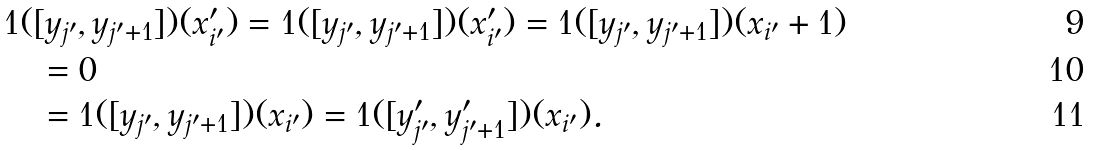Convert formula to latex. <formula><loc_0><loc_0><loc_500><loc_500>& 1 ( [ y _ { j ^ { \prime } } , y _ { j ^ { \prime } + 1 } ] ) ( x ^ { \prime } _ { i ^ { \prime } } ) = 1 ( [ y _ { j ^ { \prime } } , y _ { j ^ { \prime } + 1 } ] ) ( x ^ { \prime } _ { i ^ { \prime } } ) = 1 ( [ y _ { j ^ { \prime } } , y _ { j ^ { \prime } + 1 } ] ) ( x _ { i ^ { \prime } } + 1 ) \\ & \quad = 0 \\ & \quad = 1 ( [ y _ { j ^ { \prime } } , y _ { j ^ { \prime } + 1 } ] ) ( x _ { i ^ { \prime } } ) = 1 ( [ y ^ { \prime } _ { j ^ { \prime } } , y ^ { \prime } _ { j ^ { \prime } + 1 } ] ) ( x _ { i ^ { \prime } } ) .</formula> 